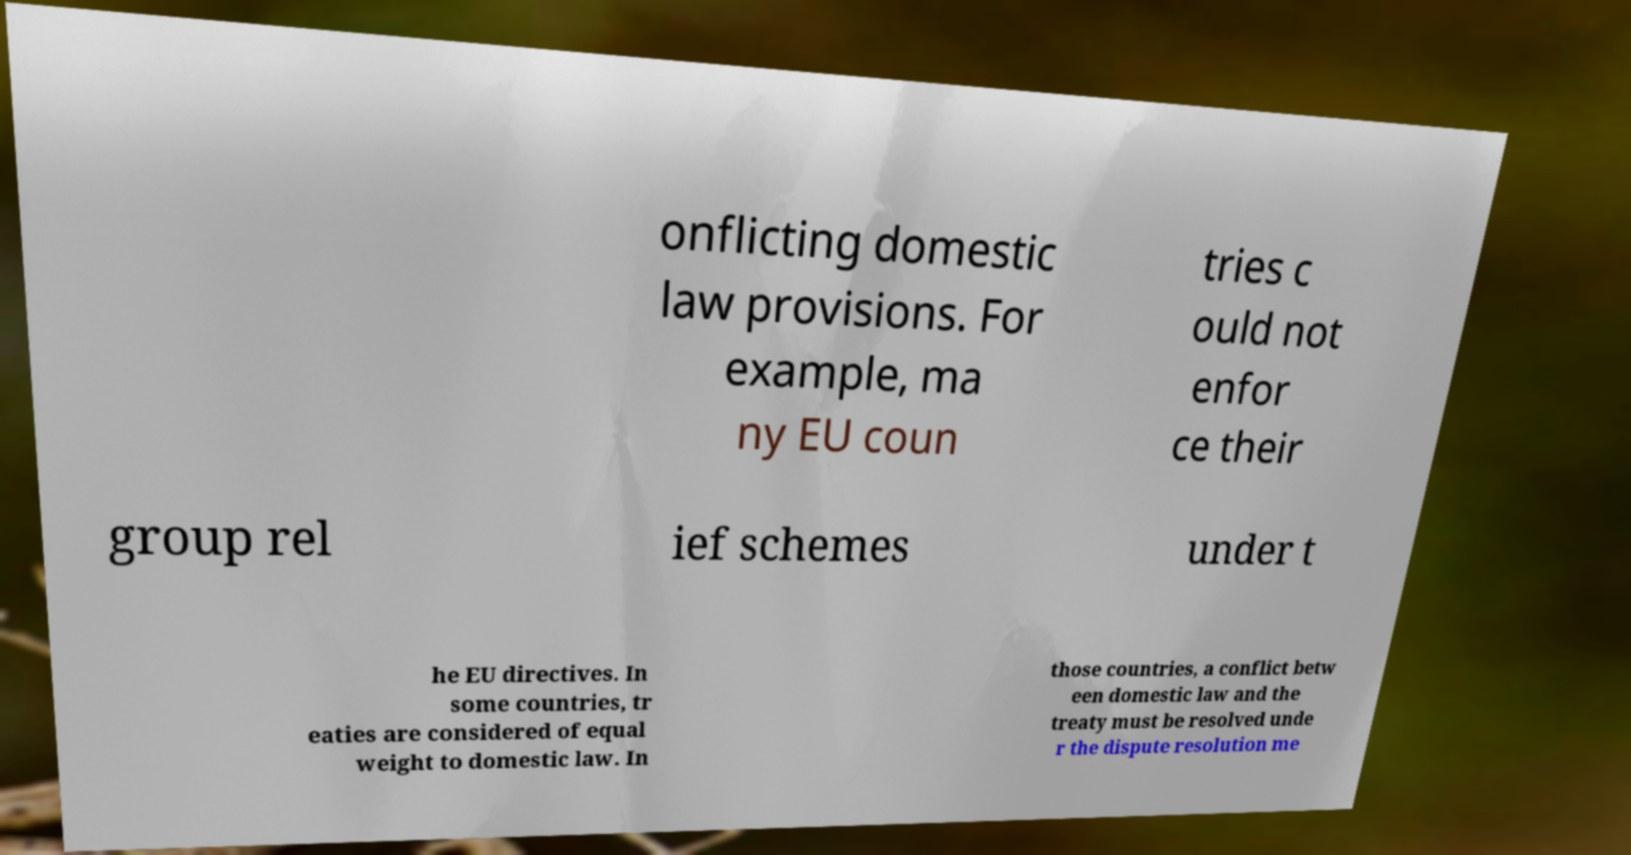For documentation purposes, I need the text within this image transcribed. Could you provide that? onflicting domestic law provisions. For example, ma ny EU coun tries c ould not enfor ce their group rel ief schemes under t he EU directives. In some countries, tr eaties are considered of equal weight to domestic law. In those countries, a conflict betw een domestic law and the treaty must be resolved unde r the dispute resolution me 